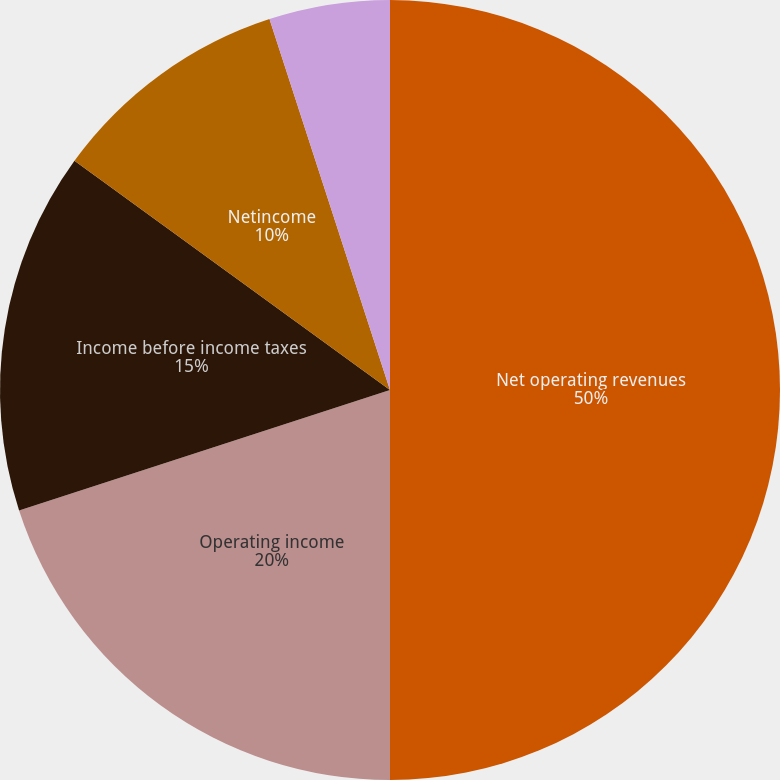<chart> <loc_0><loc_0><loc_500><loc_500><pie_chart><fcel>Net operating revenues<fcel>Operating income<fcel>Income before income taxes<fcel>Netincome<fcel>Basic net income per<fcel>Diluted net income per<nl><fcel>50.0%<fcel>20.0%<fcel>15.0%<fcel>10.0%<fcel>5.0%<fcel>0.0%<nl></chart> 